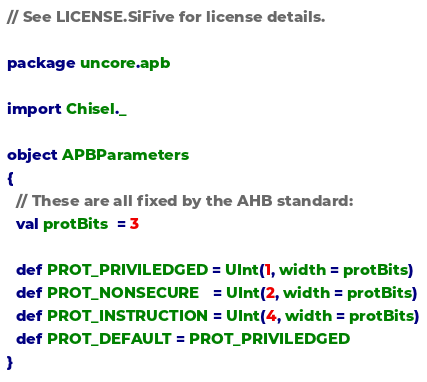<code> <loc_0><loc_0><loc_500><loc_500><_Scala_>// See LICENSE.SiFive for license details.

package uncore.apb

import Chisel._

object APBParameters
{
  // These are all fixed by the AHB standard:
  val protBits  = 3

  def PROT_PRIVILEDGED = UInt(1, width = protBits)
  def PROT_NONSECURE   = UInt(2, width = protBits)
  def PROT_INSTRUCTION = UInt(4, width = protBits)
  def PROT_DEFAULT = PROT_PRIVILEDGED
}
</code> 